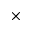Convert formula to latex. <formula><loc_0><loc_0><loc_500><loc_500>\times</formula> 